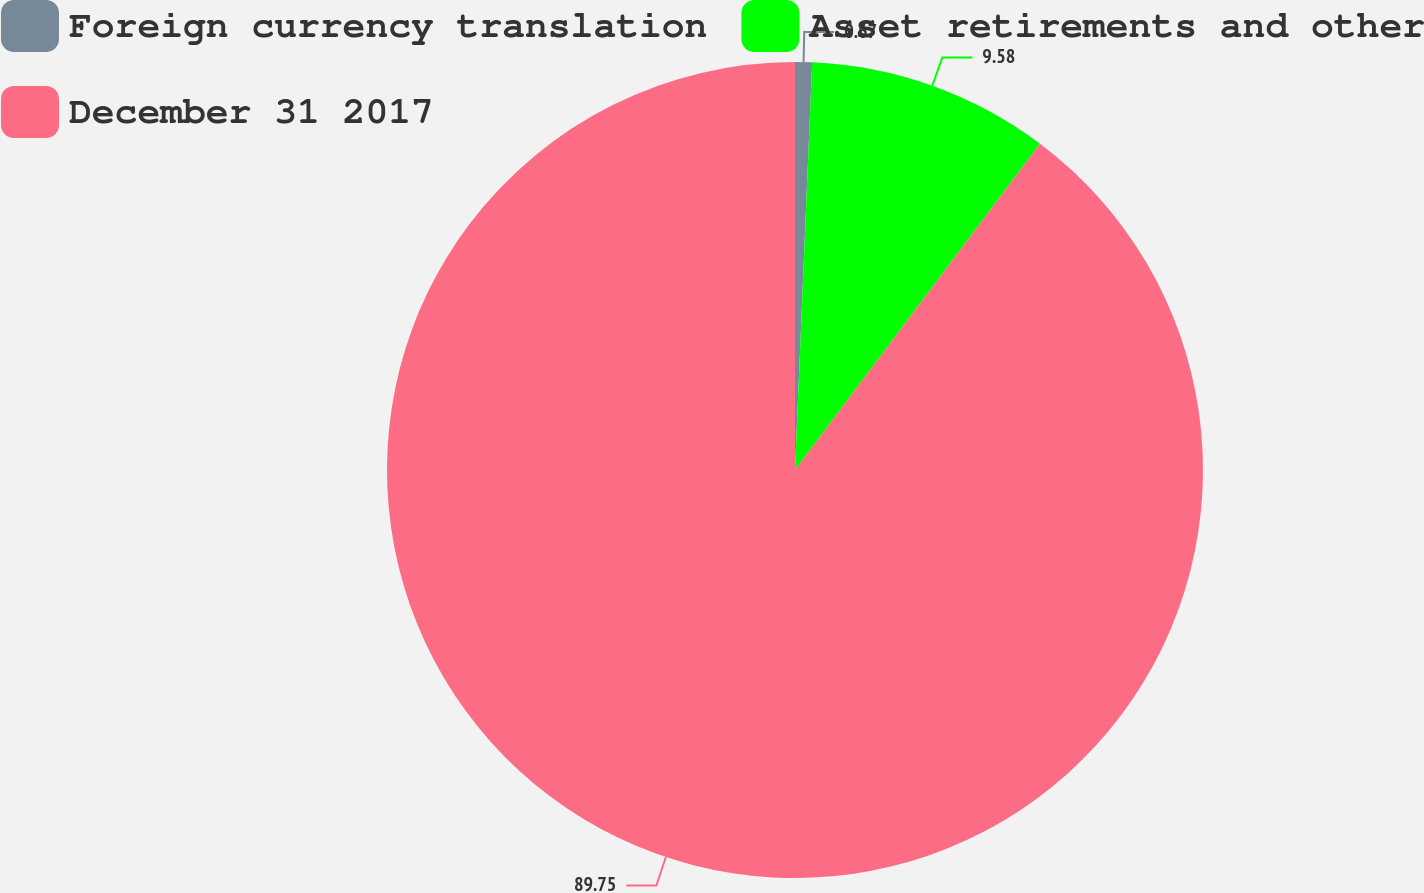<chart> <loc_0><loc_0><loc_500><loc_500><pie_chart><fcel>Foreign currency translation<fcel>Asset retirements and other<fcel>December 31 2017<nl><fcel>0.67%<fcel>9.58%<fcel>89.74%<nl></chart> 